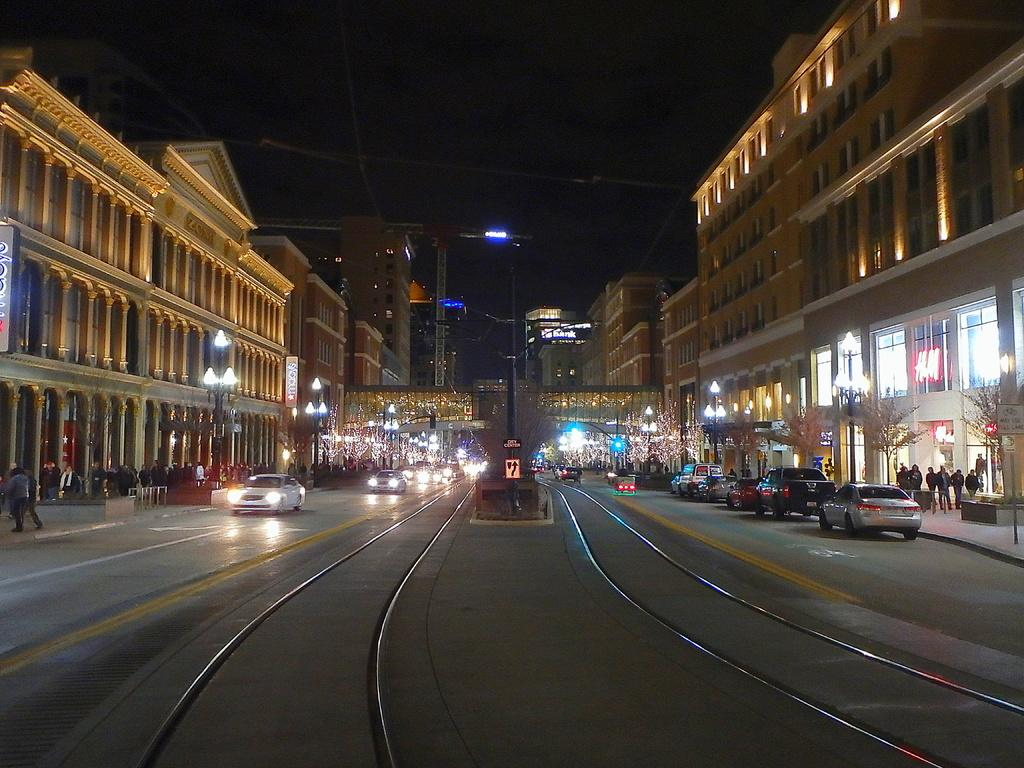What type of structures can be seen in the image? There are buildings in the image. What are the vertical objects on the sides of the road? Street poles are present in the image. What illuminates the road at night? Street lights are visible in the image. What type of vegetation is present in the image? Trees are in the image. What type of transportation is on the road? Motor vehicles are on the road in the image. Are there any people visible in the image? Yes, there are people standing on the road in the image. What part of the natural environment is visible in the image? The sky is visible in the image. What type of flame can be seen on the shirt of the person standing on the road? There is no flame visible on the shirt of the person standing on the road in the image. What type of net is being used to catch the motor vehicles on the road? There is no net present in the image, and motor vehicles are not being caught. 